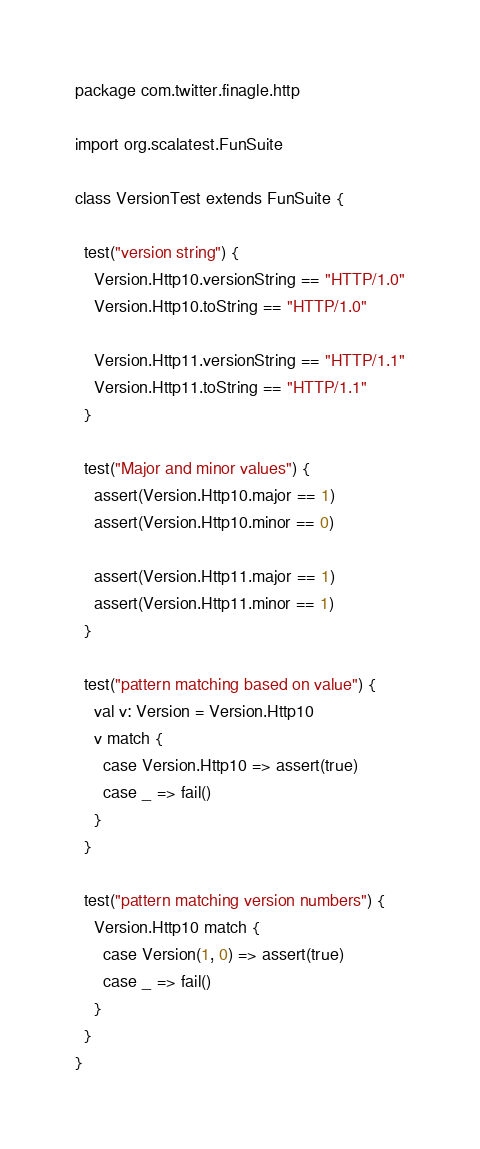Convert code to text. <code><loc_0><loc_0><loc_500><loc_500><_Scala_>package com.twitter.finagle.http

import org.scalatest.FunSuite

class VersionTest extends FunSuite {

  test("version string") {
    Version.Http10.versionString == "HTTP/1.0"
    Version.Http10.toString == "HTTP/1.0"

    Version.Http11.versionString == "HTTP/1.1"
    Version.Http11.toString == "HTTP/1.1"
  }

  test("Major and minor values") {
    assert(Version.Http10.major == 1)
    assert(Version.Http10.minor == 0)

    assert(Version.Http11.major == 1)
    assert(Version.Http11.minor == 1)
  }

  test("pattern matching based on value") {
    val v: Version = Version.Http10
    v match {
      case Version.Http10 => assert(true)
      case _ => fail()
    }
  }

  test("pattern matching version numbers") {
    Version.Http10 match {
      case Version(1, 0) => assert(true)
      case _ => fail()
    }
  }
}
</code> 